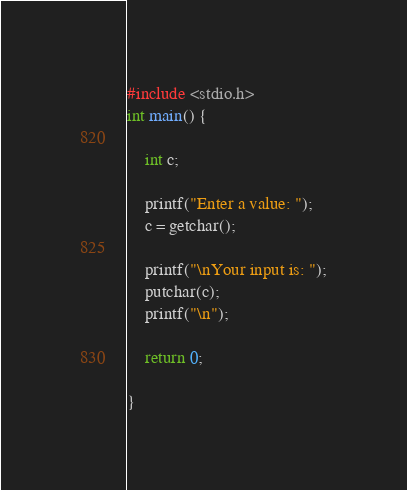Convert code to text. <code><loc_0><loc_0><loc_500><loc_500><_C_>#include <stdio.h>
int main() {

	int c;

	printf("Enter a value: ");
	c = getchar();

	printf("\nYour input is: ");
	putchar(c);
	printf("\n");

	return 0;

}
</code> 